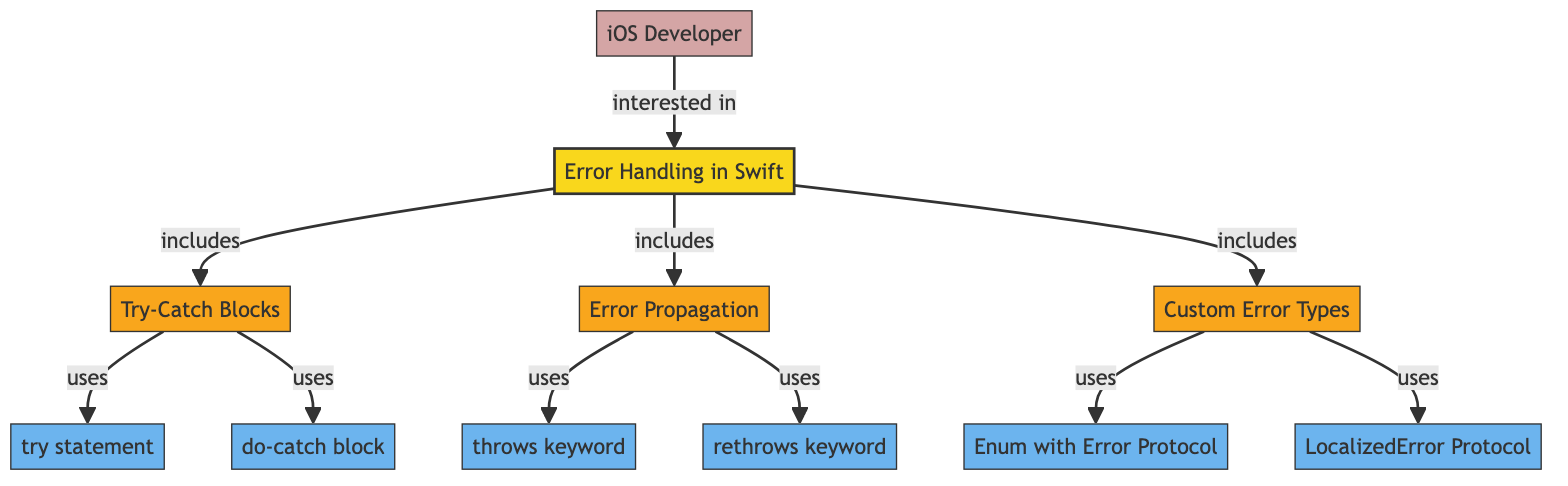What are the three main components included in error handling in Swift? The diagram specifically shows that error handling in Swift includes three main components: try-catch blocks, error propagation, and custom error types.
Answer: try-catch blocks, error propagation, custom error types How many nodes represent concepts in this diagram? By examining the diagram, we can count the nodes categorized as concepts, which are try statement, do-catch block, throws keyword, rethrows keyword, enum with Error Protocol, and LocalizedError Protocol. There are six nodes in total.
Answer: six Which block is used to handle errors in Swift? The diagram indicates that the do-catch block is the mechanism specifically used to handle errors in Swift.
Answer: do-catch block What keyword is associated with error propagation in Swift? According to the diagram, the keyword associated with error propagation is "throws keyword."
Answer: throws keyword How are custom error types represented in the diagram? The diagram shows that custom error types are represented through an "Enum with Error Protocol" and "LocalizedError Protocol," indicating the implementation of custom error types in Swift.
Answer: Enum with Error Protocol, LocalizedError Protocol What component does "iOS Developer" relate to in this diagram? The relationship indicated in the diagram shows that the iOS Developer is interested in the entire error handling mechanism in Swift, represented by the node labeled "Error Handling in Swift."
Answer: Error Handling in Swift Which two keywords are related to error propagation mechanisms? From the visual structure of the diagram, we can see that both "throws keyword" and "rethrows keyword" are linked to the error propagation mechanism in Swift.
Answer: throws keyword, rethrows keyword What is the main topic of this diagram? The diagram's main topic is clearly labeled as "Error Handling in Swift," which encapsulates the various mechanisms of error handling within the Swift programming language.
Answer: Error Handling in Swift 